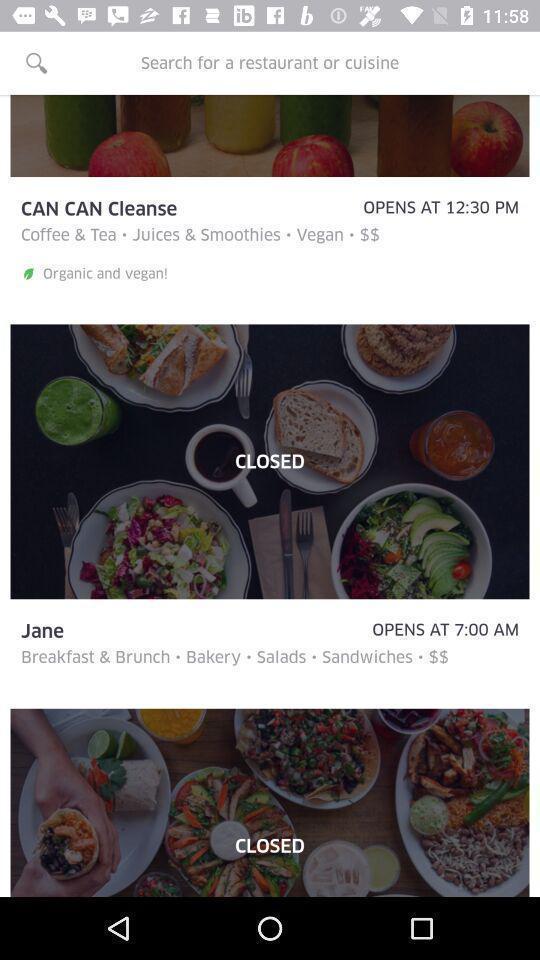Describe the content in this image. Search bar of a food ordering app. 